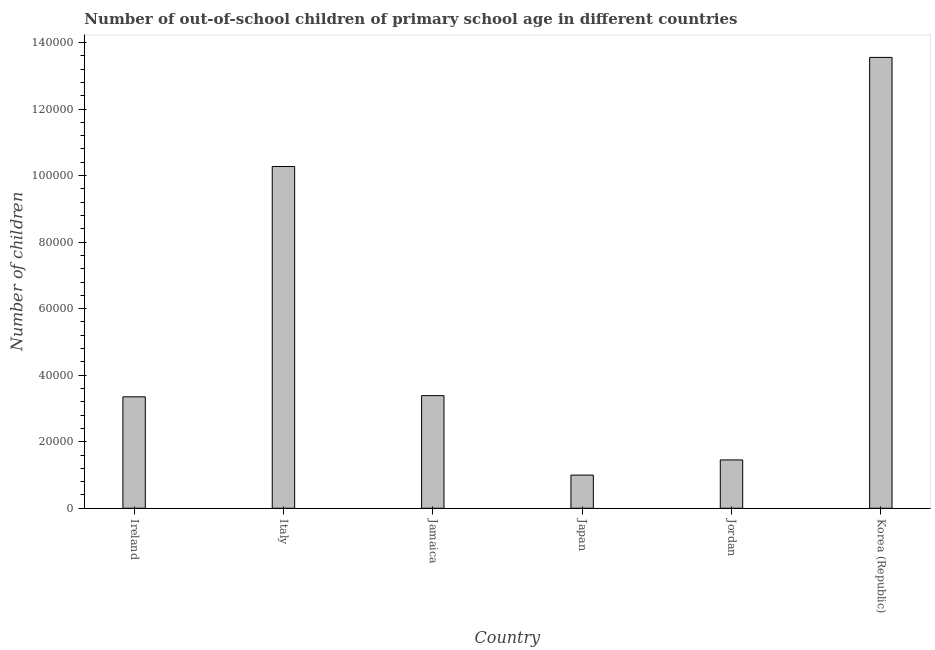Does the graph contain grids?
Keep it short and to the point. No. What is the title of the graph?
Keep it short and to the point. Number of out-of-school children of primary school age in different countries. What is the label or title of the Y-axis?
Offer a terse response. Number of children. What is the number of out-of-school children in Italy?
Provide a short and direct response. 1.03e+05. Across all countries, what is the maximum number of out-of-school children?
Ensure brevity in your answer.  1.36e+05. Across all countries, what is the minimum number of out-of-school children?
Ensure brevity in your answer.  9975. In which country was the number of out-of-school children maximum?
Keep it short and to the point. Korea (Republic). What is the sum of the number of out-of-school children?
Your response must be concise. 3.30e+05. What is the difference between the number of out-of-school children in Japan and Korea (Republic)?
Give a very brief answer. -1.26e+05. What is the average number of out-of-school children per country?
Your response must be concise. 5.50e+04. What is the median number of out-of-school children?
Give a very brief answer. 3.37e+04. In how many countries, is the number of out-of-school children greater than 128000 ?
Your answer should be very brief. 1. What is the ratio of the number of out-of-school children in Jordan to that in Korea (Republic)?
Your answer should be very brief. 0.11. Is the number of out-of-school children in Ireland less than that in Jamaica?
Ensure brevity in your answer.  Yes. Is the difference between the number of out-of-school children in Ireland and Italy greater than the difference between any two countries?
Offer a terse response. No. What is the difference between the highest and the second highest number of out-of-school children?
Your answer should be compact. 3.28e+04. Is the sum of the number of out-of-school children in Ireland and Korea (Republic) greater than the maximum number of out-of-school children across all countries?
Provide a succinct answer. Yes. What is the difference between the highest and the lowest number of out-of-school children?
Your answer should be very brief. 1.26e+05. How many bars are there?
Ensure brevity in your answer.  6. Are all the bars in the graph horizontal?
Make the answer very short. No. What is the difference between two consecutive major ticks on the Y-axis?
Offer a very short reply. 2.00e+04. What is the Number of children in Ireland?
Provide a succinct answer. 3.35e+04. What is the Number of children of Italy?
Ensure brevity in your answer.  1.03e+05. What is the Number of children in Jamaica?
Keep it short and to the point. 3.39e+04. What is the Number of children in Japan?
Offer a terse response. 9975. What is the Number of children of Jordan?
Your response must be concise. 1.45e+04. What is the Number of children in Korea (Republic)?
Your answer should be compact. 1.36e+05. What is the difference between the Number of children in Ireland and Italy?
Your response must be concise. -6.92e+04. What is the difference between the Number of children in Ireland and Jamaica?
Your answer should be compact. -362. What is the difference between the Number of children in Ireland and Japan?
Make the answer very short. 2.35e+04. What is the difference between the Number of children in Ireland and Jordan?
Ensure brevity in your answer.  1.90e+04. What is the difference between the Number of children in Ireland and Korea (Republic)?
Provide a short and direct response. -1.02e+05. What is the difference between the Number of children in Italy and Jamaica?
Offer a terse response. 6.89e+04. What is the difference between the Number of children in Italy and Japan?
Keep it short and to the point. 9.27e+04. What is the difference between the Number of children in Italy and Jordan?
Provide a succinct answer. 8.82e+04. What is the difference between the Number of children in Italy and Korea (Republic)?
Provide a short and direct response. -3.28e+04. What is the difference between the Number of children in Jamaica and Japan?
Your response must be concise. 2.39e+04. What is the difference between the Number of children in Jamaica and Jordan?
Your answer should be compact. 1.93e+04. What is the difference between the Number of children in Jamaica and Korea (Republic)?
Offer a very short reply. -1.02e+05. What is the difference between the Number of children in Japan and Jordan?
Provide a succinct answer. -4557. What is the difference between the Number of children in Japan and Korea (Republic)?
Provide a short and direct response. -1.26e+05. What is the difference between the Number of children in Jordan and Korea (Republic)?
Make the answer very short. -1.21e+05. What is the ratio of the Number of children in Ireland to that in Italy?
Offer a very short reply. 0.33. What is the ratio of the Number of children in Ireland to that in Japan?
Provide a short and direct response. 3.36. What is the ratio of the Number of children in Ireland to that in Jordan?
Offer a very short reply. 2.31. What is the ratio of the Number of children in Ireland to that in Korea (Republic)?
Offer a very short reply. 0.25. What is the ratio of the Number of children in Italy to that in Jamaica?
Your answer should be very brief. 3.03. What is the ratio of the Number of children in Italy to that in Japan?
Provide a succinct answer. 10.3. What is the ratio of the Number of children in Italy to that in Jordan?
Keep it short and to the point. 7.07. What is the ratio of the Number of children in Italy to that in Korea (Republic)?
Your response must be concise. 0.76. What is the ratio of the Number of children in Jamaica to that in Japan?
Your response must be concise. 3.39. What is the ratio of the Number of children in Jamaica to that in Jordan?
Ensure brevity in your answer.  2.33. What is the ratio of the Number of children in Japan to that in Jordan?
Ensure brevity in your answer.  0.69. What is the ratio of the Number of children in Japan to that in Korea (Republic)?
Your answer should be very brief. 0.07. What is the ratio of the Number of children in Jordan to that in Korea (Republic)?
Keep it short and to the point. 0.11. 